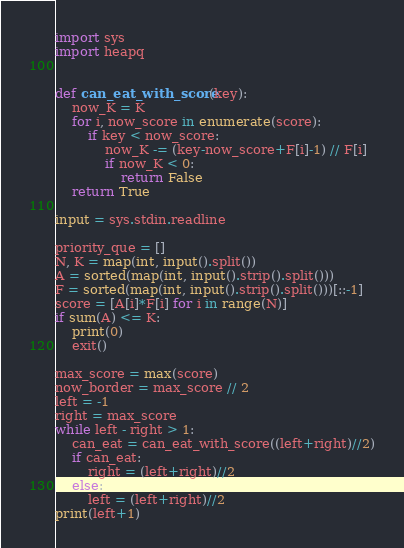Convert code to text. <code><loc_0><loc_0><loc_500><loc_500><_Python_>import sys
import heapq


def can_eat_with_score(key):
    now_K = K
    for i, now_score in enumerate(score):
        if key < now_score:
            now_K -= (key-now_score+F[i]-1) // F[i]
            if now_K < 0:
                return False
    return True

input = sys.stdin.readline

priority_que = []
N, K = map(int, input().split())
A = sorted(map(int, input().strip().split()))
F = sorted(map(int, input().strip().split()))[::-1]
score = [A[i]*F[i] for i in range(N)]
if sum(A) <= K:
    print(0)
    exit()

max_score = max(score)
now_border = max_score // 2
left = -1
right = max_score
while left - right > 1:
    can_eat = can_eat_with_score((left+right)//2)
    if can_eat:
        right = (left+right)//2
    else:
        left = (left+right)//2
print(left+1)
</code> 